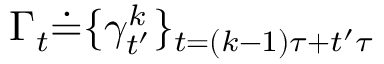<formula> <loc_0><loc_0><loc_500><loc_500>\Gamma _ { t } \dot { = } \{ \gamma _ { t ^ { \prime } } ^ { k } \} _ { t = ( k - 1 ) \tau + t ^ { \prime } \tau }</formula> 